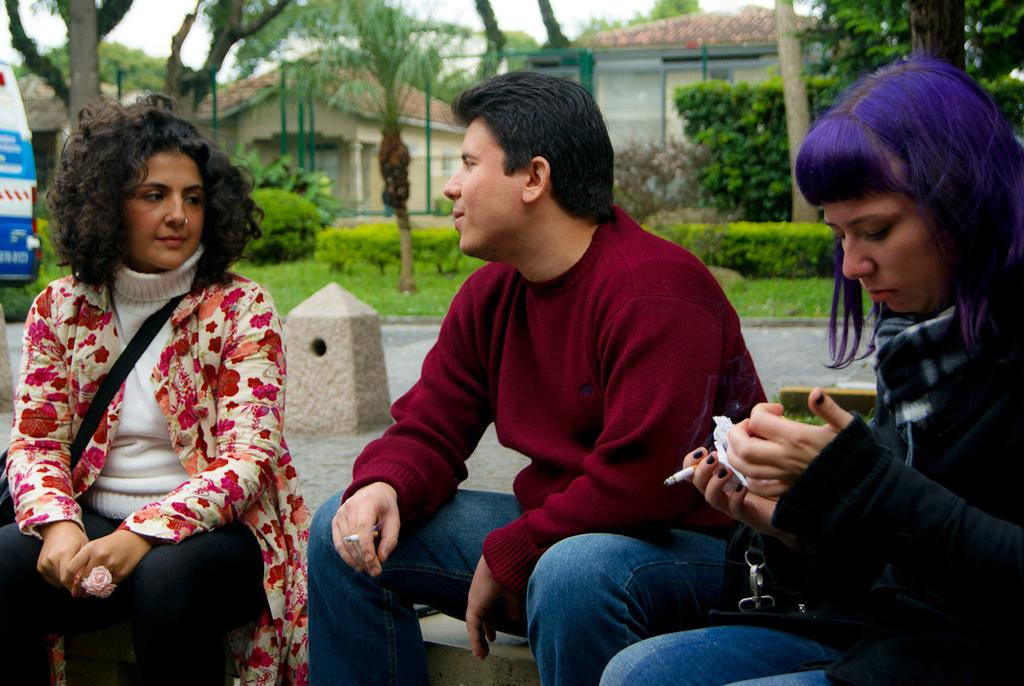What are the people in the image doing? The people in the image are sitting on the ground. What are the people holding in their hands? The people are holding cigarettes. What can be seen in the background of the image? There are trees, grass, a vehicle, houses, rods, and the sky visible in the background. What type of sign can be seen in the image? There is no sign present in the image. What kind of meeting is taking place in the image? There is no meeting depicted in the image; it shows people sitting on the ground holding cigarettes. 